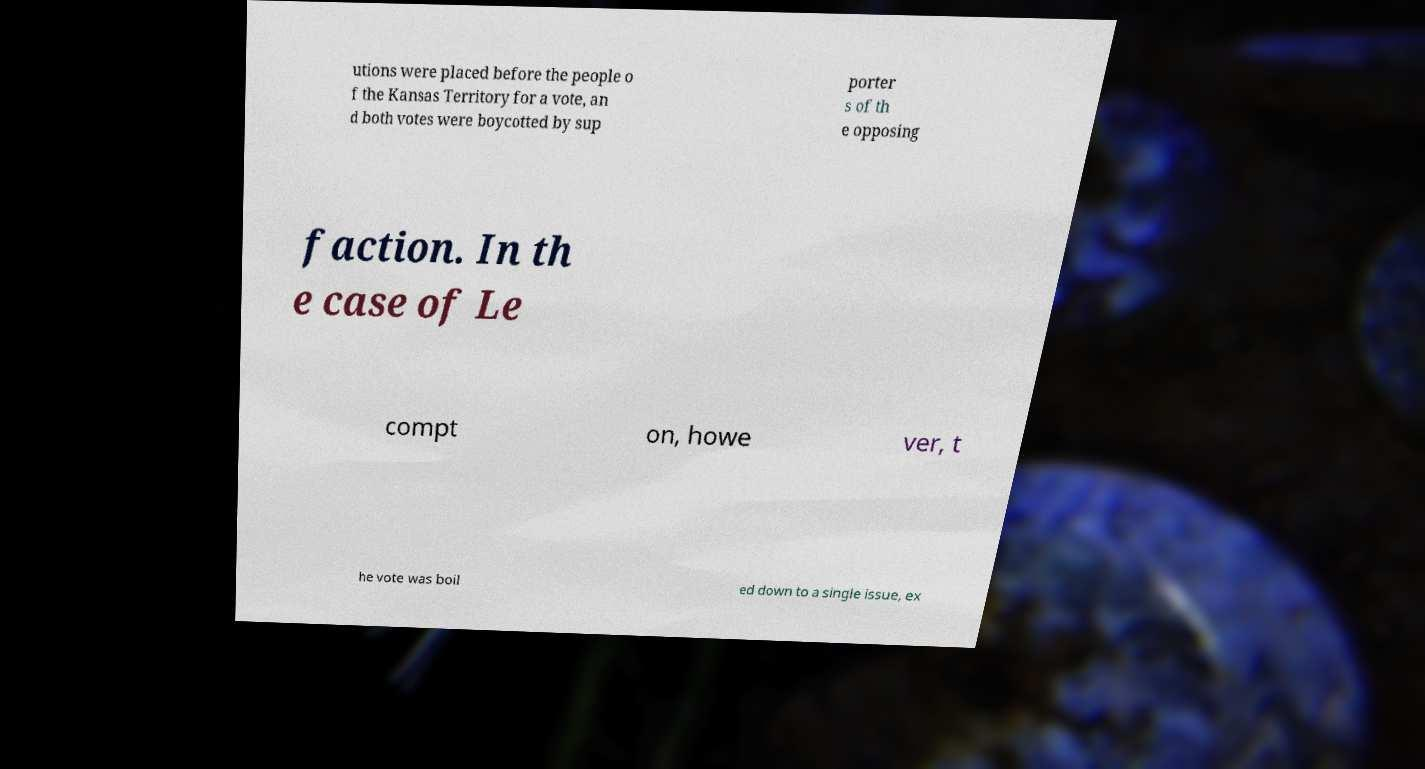Please identify and transcribe the text found in this image. utions were placed before the people o f the Kansas Territory for a vote, an d both votes were boycotted by sup porter s of th e opposing faction. In th e case of Le compt on, howe ver, t he vote was boil ed down to a single issue, ex 